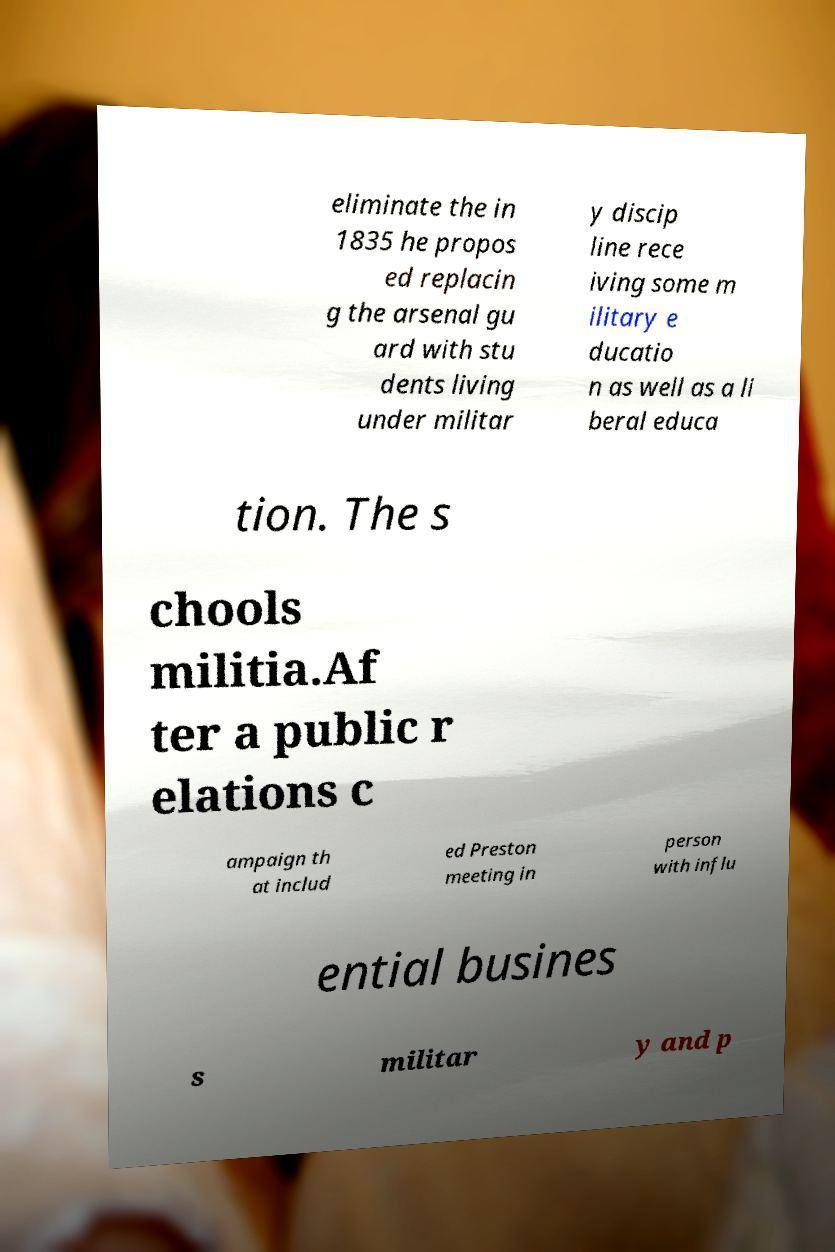For documentation purposes, I need the text within this image transcribed. Could you provide that? eliminate the in 1835 he propos ed replacin g the arsenal gu ard with stu dents living under militar y discip line rece iving some m ilitary e ducatio n as well as a li beral educa tion. The s chools militia.Af ter a public r elations c ampaign th at includ ed Preston meeting in person with influ ential busines s militar y and p 